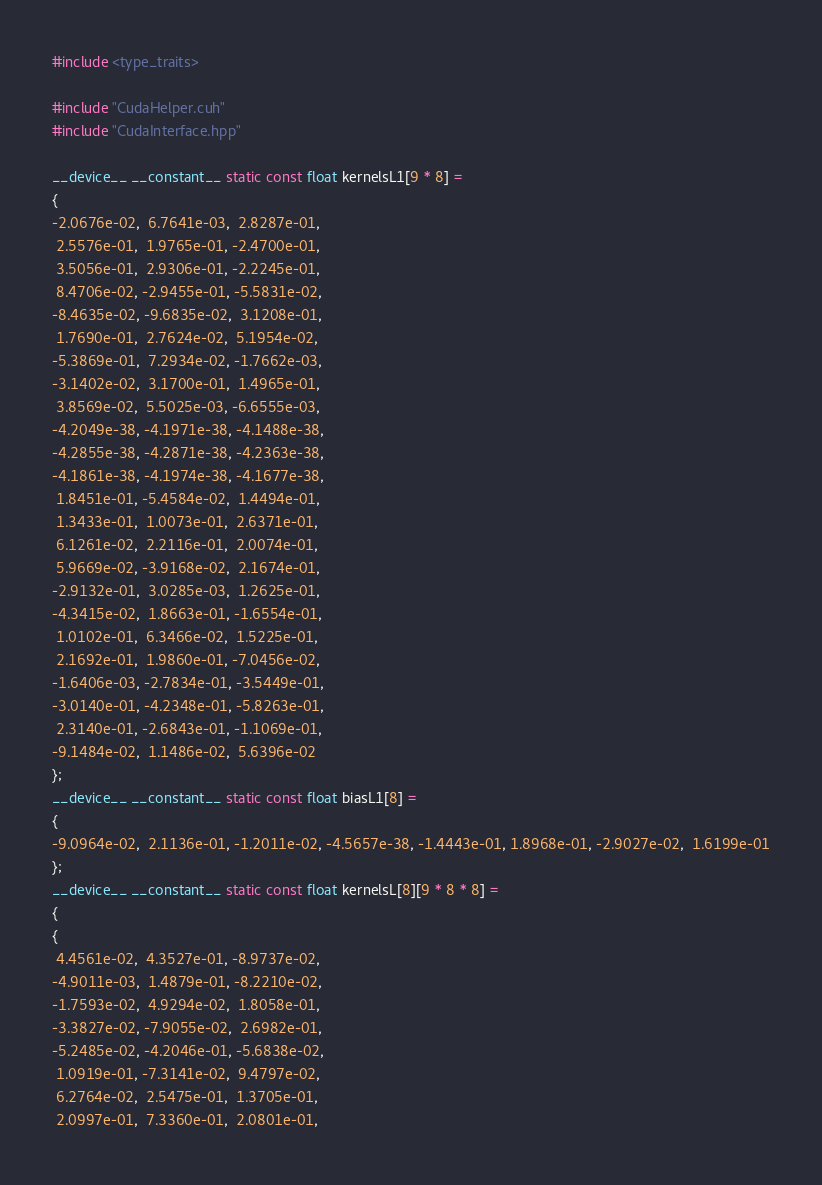Convert code to text. <code><loc_0><loc_0><loc_500><loc_500><_Cuda_>#include <type_traits>

#include "CudaHelper.cuh"
#include "CudaInterface.hpp"

__device__ __constant__ static const float kernelsL1[9 * 8] =
{
-2.0676e-02,  6.7641e-03,  2.8287e-01,
 2.5576e-01,  1.9765e-01, -2.4700e-01,
 3.5056e-01,  2.9306e-01, -2.2245e-01,
 8.4706e-02, -2.9455e-01, -5.5831e-02,
-8.4635e-02, -9.6835e-02,  3.1208e-01,
 1.7690e-01,  2.7624e-02,  5.1954e-02,
-5.3869e-01,  7.2934e-02, -1.7662e-03,
-3.1402e-02,  3.1700e-01,  1.4965e-01,
 3.8569e-02,  5.5025e-03, -6.6555e-03,
-4.2049e-38, -4.1971e-38, -4.1488e-38,
-4.2855e-38, -4.2871e-38, -4.2363e-38,
-4.1861e-38, -4.1974e-38, -4.1677e-38,
 1.8451e-01, -5.4584e-02,  1.4494e-01,
 1.3433e-01,  1.0073e-01,  2.6371e-01,
 6.1261e-02,  2.2116e-01,  2.0074e-01,
 5.9669e-02, -3.9168e-02,  2.1674e-01,
-2.9132e-01,  3.0285e-03,  1.2625e-01,
-4.3415e-02,  1.8663e-01, -1.6554e-01,
 1.0102e-01,  6.3466e-02,  1.5225e-01,
 2.1692e-01,  1.9860e-01, -7.0456e-02,
-1.6406e-03, -2.7834e-01, -3.5449e-01,
-3.0140e-01, -4.2348e-01, -5.8263e-01,
 2.3140e-01, -2.6843e-01, -1.1069e-01,
-9.1484e-02,  1.1486e-02,  5.6396e-02
};
__device__ __constant__ static const float biasL1[8] =
{
-9.0964e-02,  2.1136e-01, -1.2011e-02, -4.5657e-38, -1.4443e-01, 1.8968e-01, -2.9027e-02,  1.6199e-01
};
__device__ __constant__ static const float kernelsL[8][9 * 8 * 8] =
{
{
 4.4561e-02,  4.3527e-01, -8.9737e-02,
-4.9011e-03,  1.4879e-01, -8.2210e-02,
-1.7593e-02,  4.9294e-02,  1.8058e-01,
-3.3827e-02, -7.9055e-02,  2.6982e-01,
-5.2485e-02, -4.2046e-01, -5.6838e-02,
 1.0919e-01, -7.3141e-02,  9.4797e-02,
 6.2764e-02,  2.5475e-01,  1.3705e-01,
 2.0997e-01,  7.3360e-01,  2.0801e-01,</code> 